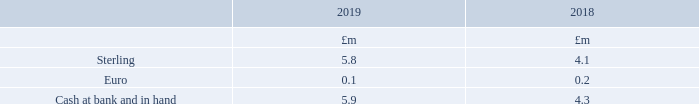19. Cash and cash equivalents
Cash at bank and in hand is denominated in the following currencies:
Cash balances with an original maturity of less than three months were held in current accounts during the year and attracted interest at a weighted average rate of 0.3% (2018: 0.3%).
What were the currencies in which cash at bank and in hand was denominated in? Sterling, euro. In which year was Sterling larger? 5.8>4.1
Answer: 2019. What was the change in Cash at bank and in hand in 2019 from 2018?
Answer scale should be: million. 5.9-4.3
Answer: 1.6. What was the percentage change in Cash at bank and in hand in 2019 from 2018?
Answer scale should be: percent. (5.9-4.3)/4.3
Answer: 37.21. Where were cash balances with an original maturity of less than three months held in? Held in current accounts during the year. What was the amount of interest attracted by cash balances in 2019? Weighted average rate of 0.3%. 